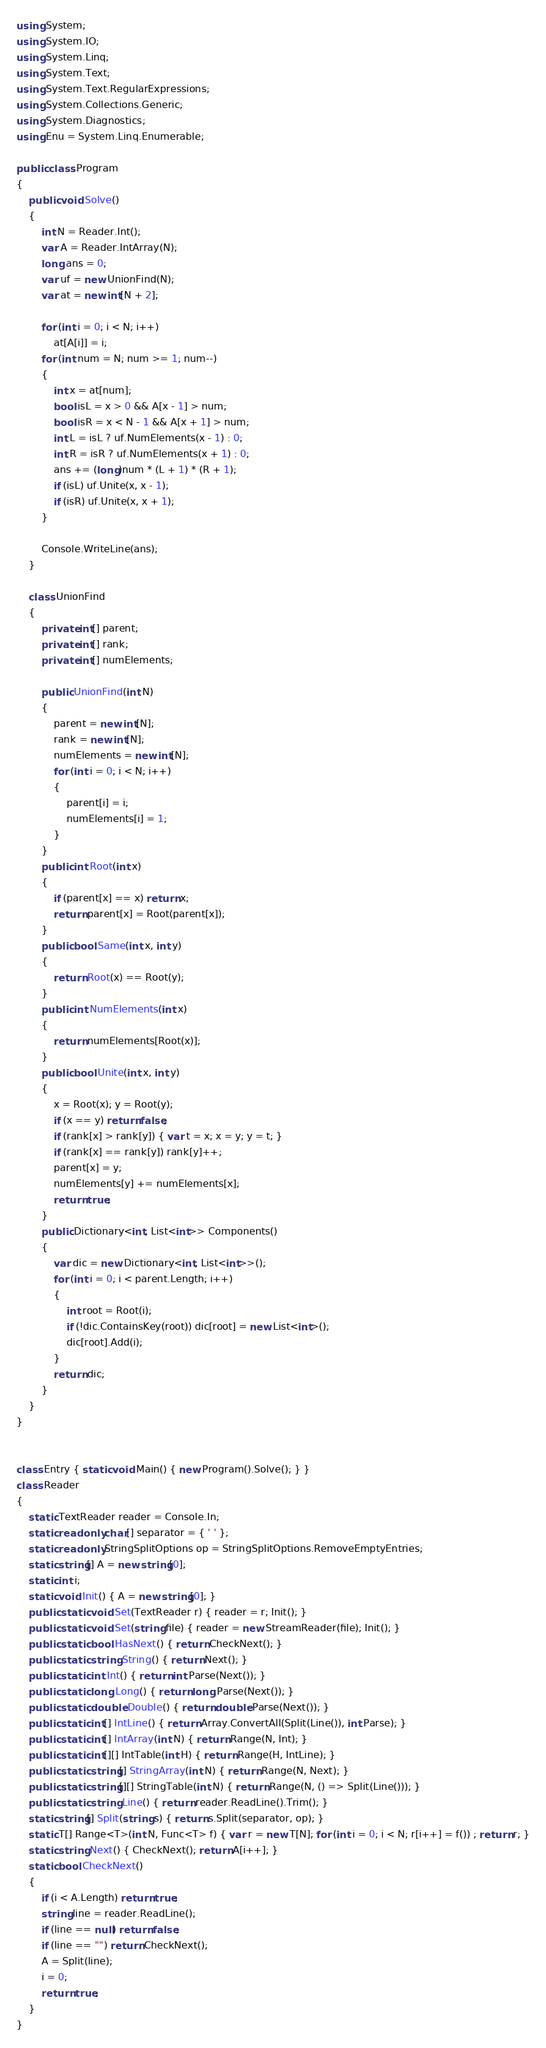Convert code to text. <code><loc_0><loc_0><loc_500><loc_500><_C#_>using System;
using System.IO;
using System.Linq;
using System.Text;
using System.Text.RegularExpressions;
using System.Collections.Generic;
using System.Diagnostics;
using Enu = System.Linq.Enumerable;

public class Program
{
    public void Solve()
    {
        int N = Reader.Int();
        var A = Reader.IntArray(N);
        long ans = 0;
        var uf = new UnionFind(N);
        var at = new int[N + 2];

        for (int i = 0; i < N; i++)
            at[A[i]] = i;
        for (int num = N; num >= 1; num--)
        {
            int x = at[num];
            bool isL = x > 0 && A[x - 1] > num;
            bool isR = x < N - 1 && A[x + 1] > num;
            int L = isL ? uf.NumElements(x - 1) : 0;
            int R = isR ? uf.NumElements(x + 1) : 0;
            ans += (long)num * (L + 1) * (R + 1);
            if (isL) uf.Unite(x, x - 1);
            if (isR) uf.Unite(x, x + 1);
        }

        Console.WriteLine(ans);
    }

    class UnionFind
    {
        private int[] parent;
        private int[] rank;
        private int[] numElements;

        public UnionFind(int N)
        {
            parent = new int[N];
            rank = new int[N];
            numElements = new int[N];
            for (int i = 0; i < N; i++)
            {
                parent[i] = i;
                numElements[i] = 1;
            }
        }
        public int Root(int x)
        {
            if (parent[x] == x) return x;
            return parent[x] = Root(parent[x]);
        }
        public bool Same(int x, int y)
        {
            return Root(x) == Root(y);
        }
        public int NumElements(int x)
        {
            return numElements[Root(x)];
        }
        public bool Unite(int x, int y)
        {
            x = Root(x); y = Root(y);
            if (x == y) return false;
            if (rank[x] > rank[y]) { var t = x; x = y; y = t; }
            if (rank[x] == rank[y]) rank[y]++;
            parent[x] = y;
            numElements[y] += numElements[x];
            return true;
        }
        public Dictionary<int, List<int>> Components()
        {
            var dic = new Dictionary<int, List<int>>();
            for (int i = 0; i < parent.Length; i++)
            {
                int root = Root(i);
                if (!dic.ContainsKey(root)) dic[root] = new List<int>();
                dic[root].Add(i);
            }
            return dic;
        }
    }
}


class Entry { static void Main() { new Program().Solve(); } }
class Reader
{
    static TextReader reader = Console.In;
    static readonly char[] separator = { ' ' };
    static readonly StringSplitOptions op = StringSplitOptions.RemoveEmptyEntries;
    static string[] A = new string[0];
    static int i;
    static void Init() { A = new string[0]; }
    public static void Set(TextReader r) { reader = r; Init(); }
    public static void Set(string file) { reader = new StreamReader(file); Init(); }
    public static bool HasNext() { return CheckNext(); }
    public static string String() { return Next(); }
    public static int Int() { return int.Parse(Next()); }
    public static long Long() { return long.Parse(Next()); }
    public static double Double() { return double.Parse(Next()); }
    public static int[] IntLine() { return Array.ConvertAll(Split(Line()), int.Parse); }
    public static int[] IntArray(int N) { return Range(N, Int); }
    public static int[][] IntTable(int H) { return Range(H, IntLine); }
    public static string[] StringArray(int N) { return Range(N, Next); }
    public static string[][] StringTable(int N) { return Range(N, () => Split(Line())); }
    public static string Line() { return reader.ReadLine().Trim(); }
    static string[] Split(string s) { return s.Split(separator, op); }
    static T[] Range<T>(int N, Func<T> f) { var r = new T[N]; for (int i = 0; i < N; r[i++] = f()) ; return r; }
    static string Next() { CheckNext(); return A[i++]; }
    static bool CheckNext()
    {
        if (i < A.Length) return true;
        string line = reader.ReadLine();
        if (line == null) return false;
        if (line == "") return CheckNext();
        A = Split(line);
        i = 0;
        return true;
    }
}</code> 